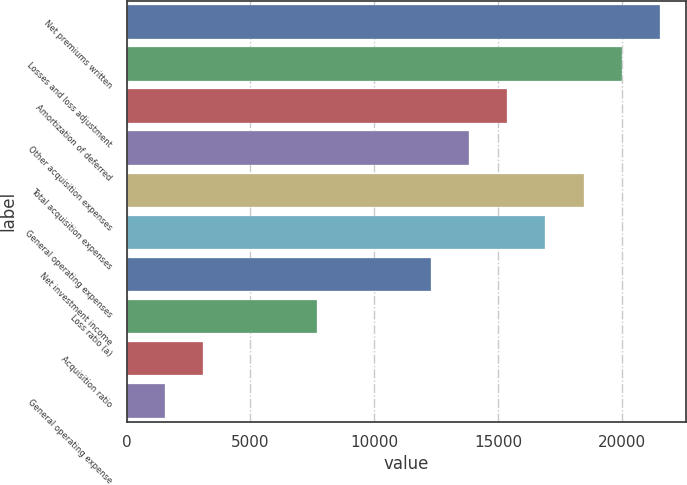Convert chart. <chart><loc_0><loc_0><loc_500><loc_500><bar_chart><fcel>Net premiums written<fcel>Losses and loss adjustment<fcel>Amortization of deferred<fcel>Other acquisition expenses<fcel>Total acquisition expenses<fcel>General operating expenses<fcel>Net investment income<fcel>Loss ratio (a)<fcel>Acquisition ratio<fcel>General operating expense<nl><fcel>21512.8<fcel>19976.3<fcel>15367<fcel>13830.6<fcel>18439.9<fcel>16903.4<fcel>12294.1<fcel>7684.8<fcel>3075.48<fcel>1539.04<nl></chart> 